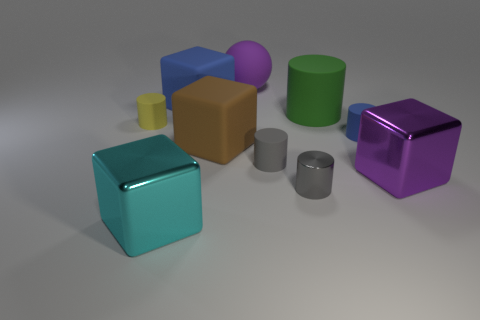What number of things are there?
Ensure brevity in your answer.  10. Does the blue cylinder have the same size as the rubber ball?
Ensure brevity in your answer.  No. How many other objects are there of the same shape as the brown rubber object?
Your answer should be compact. 3. There is a purple thing that is in front of the large matte block that is behind the big green rubber cylinder; what is it made of?
Ensure brevity in your answer.  Metal. Are there any large green objects in front of the small gray rubber cylinder?
Your answer should be compact. No. There is a green thing; does it have the same size as the blue rubber object that is on the right side of the purple sphere?
Your answer should be very brief. No. What size is the green rubber object that is the same shape as the small gray matte thing?
Keep it short and to the point. Large. Are there any other things that have the same material as the big blue block?
Make the answer very short. Yes. Is the size of the cylinder that is behind the tiny yellow rubber thing the same as the shiny object that is on the left side of the matte ball?
Your answer should be compact. Yes. What number of big objects are brown matte things or gray shiny objects?
Ensure brevity in your answer.  1. 